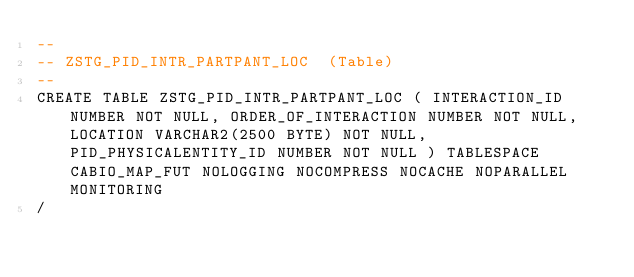<code> <loc_0><loc_0><loc_500><loc_500><_SQL_>--
-- ZSTG_PID_INTR_PARTPANT_LOC  (Table) 
--
CREATE TABLE ZSTG_PID_INTR_PARTPANT_LOC ( INTERACTION_ID NUMBER NOT NULL, ORDER_OF_INTERACTION NUMBER NOT NULL, LOCATION VARCHAR2(2500 BYTE) NOT NULL, PID_PHYSICALENTITY_ID NUMBER NOT NULL ) TABLESPACE CABIO_MAP_FUT NOLOGGING NOCOMPRESS NOCACHE NOPARALLEL MONITORING
/


</code> 